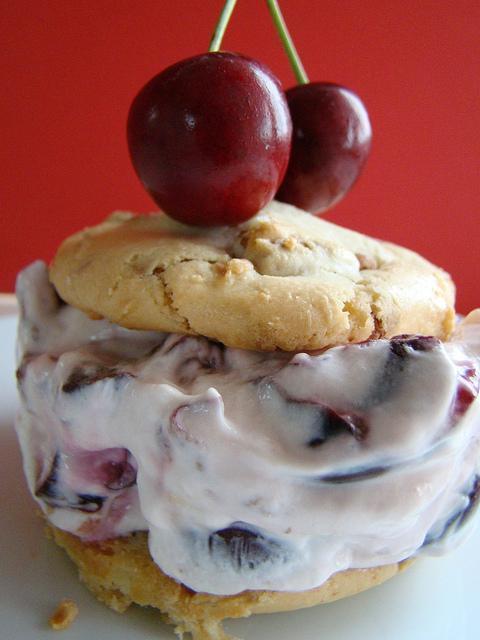How many cherries are on top?
Give a very brief answer. 2. How many apples are there?
Give a very brief answer. 2. How many men are standing in this room?
Give a very brief answer. 0. 